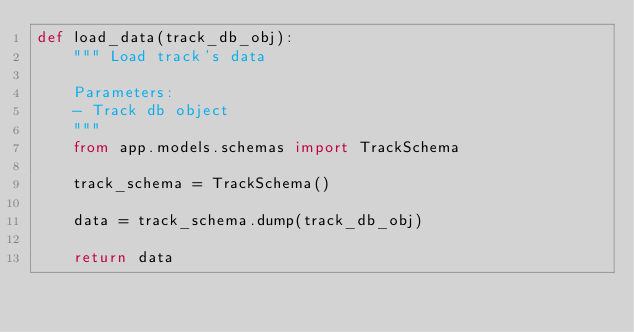Convert code to text. <code><loc_0><loc_0><loc_500><loc_500><_Python_>def load_data(track_db_obj):
    """ Load track's data

    Parameters:
    - Track db object
    """
    from app.models.schemas import TrackSchema

    track_schema = TrackSchema()

    data = track_schema.dump(track_db_obj)

    return data
</code> 